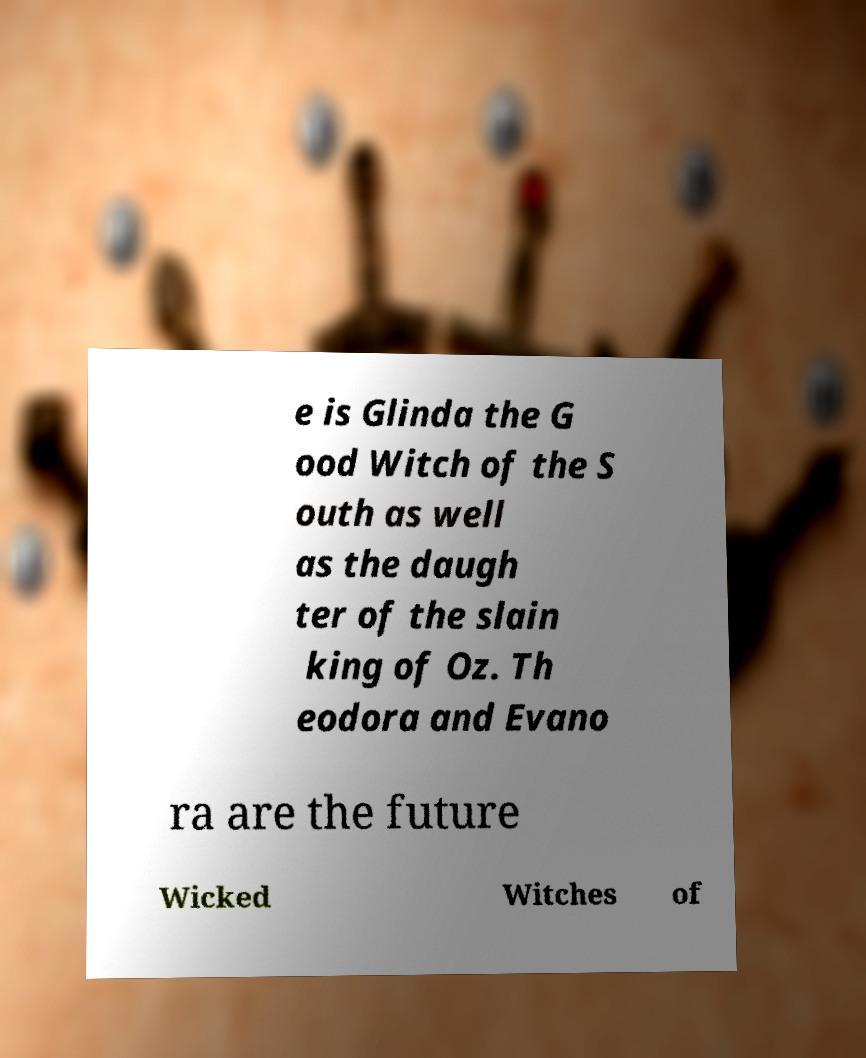For documentation purposes, I need the text within this image transcribed. Could you provide that? e is Glinda the G ood Witch of the S outh as well as the daugh ter of the slain king of Oz. Th eodora and Evano ra are the future Wicked Witches of 